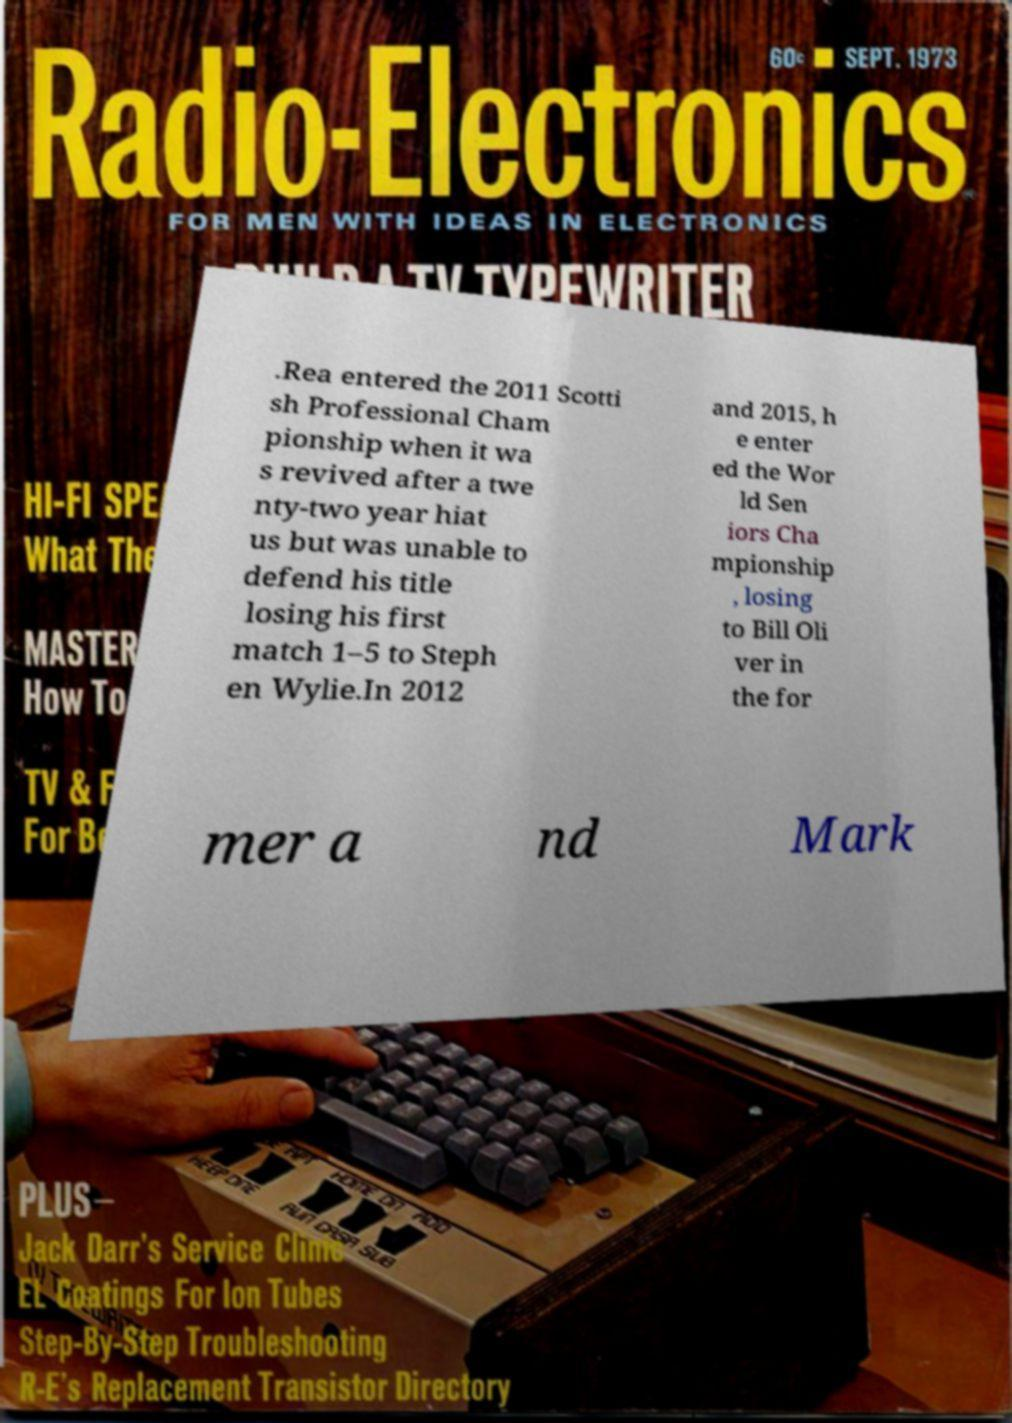Can you accurately transcribe the text from the provided image for me? .Rea entered the 2011 Scotti sh Professional Cham pionship when it wa s revived after a twe nty-two year hiat us but was unable to defend his title losing his first match 1–5 to Steph en Wylie.In 2012 and 2015, h e enter ed the Wor ld Sen iors Cha mpionship , losing to Bill Oli ver in the for mer a nd Mark 